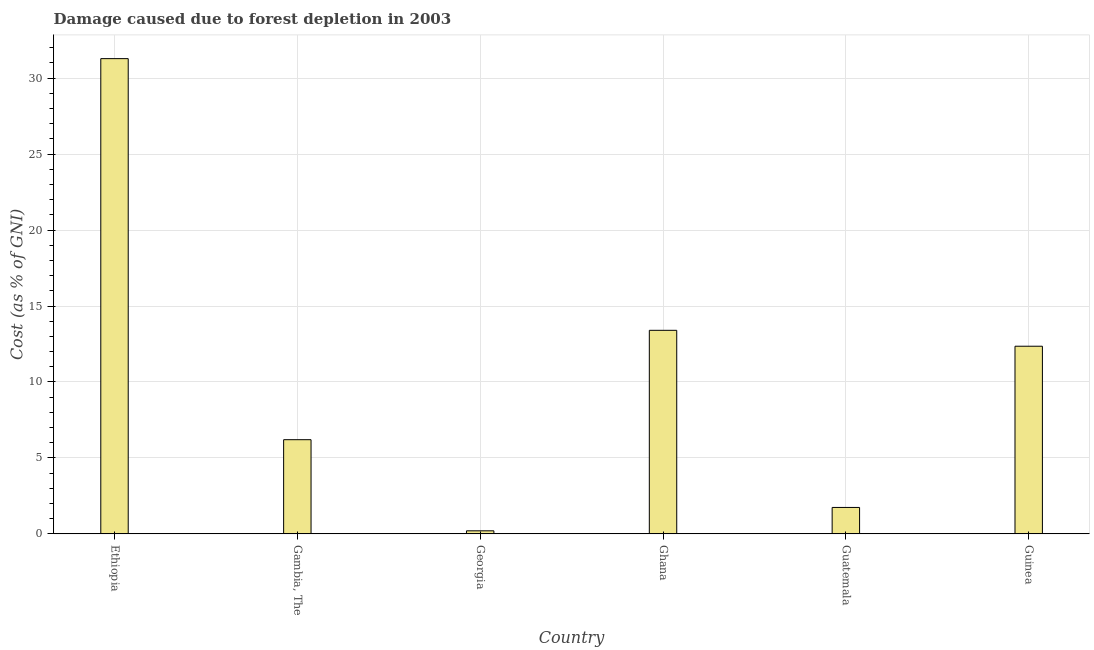Does the graph contain grids?
Your response must be concise. Yes. What is the title of the graph?
Your answer should be very brief. Damage caused due to forest depletion in 2003. What is the label or title of the Y-axis?
Offer a very short reply. Cost (as % of GNI). What is the damage caused due to forest depletion in Guatemala?
Provide a succinct answer. 1.74. Across all countries, what is the maximum damage caused due to forest depletion?
Your answer should be very brief. 31.29. Across all countries, what is the minimum damage caused due to forest depletion?
Your answer should be compact. 0.2. In which country was the damage caused due to forest depletion maximum?
Your answer should be very brief. Ethiopia. In which country was the damage caused due to forest depletion minimum?
Provide a short and direct response. Georgia. What is the sum of the damage caused due to forest depletion?
Offer a terse response. 65.18. What is the difference between the damage caused due to forest depletion in Ethiopia and Guinea?
Offer a terse response. 18.93. What is the average damage caused due to forest depletion per country?
Provide a short and direct response. 10.86. What is the median damage caused due to forest depletion?
Offer a very short reply. 9.28. What is the ratio of the damage caused due to forest depletion in Ethiopia to that in Guinea?
Provide a succinct answer. 2.53. Is the difference between the damage caused due to forest depletion in Georgia and Ghana greater than the difference between any two countries?
Offer a very short reply. No. What is the difference between the highest and the second highest damage caused due to forest depletion?
Your answer should be very brief. 17.89. Is the sum of the damage caused due to forest depletion in Gambia, The and Guatemala greater than the maximum damage caused due to forest depletion across all countries?
Your answer should be very brief. No. What is the difference between the highest and the lowest damage caused due to forest depletion?
Provide a short and direct response. 31.09. In how many countries, is the damage caused due to forest depletion greater than the average damage caused due to forest depletion taken over all countries?
Provide a short and direct response. 3. What is the difference between two consecutive major ticks on the Y-axis?
Your response must be concise. 5. What is the Cost (as % of GNI) of Ethiopia?
Keep it short and to the point. 31.29. What is the Cost (as % of GNI) in Gambia, The?
Offer a very short reply. 6.2. What is the Cost (as % of GNI) in Georgia?
Make the answer very short. 0.2. What is the Cost (as % of GNI) in Ghana?
Offer a very short reply. 13.4. What is the Cost (as % of GNI) of Guatemala?
Make the answer very short. 1.74. What is the Cost (as % of GNI) of Guinea?
Keep it short and to the point. 12.35. What is the difference between the Cost (as % of GNI) in Ethiopia and Gambia, The?
Give a very brief answer. 25.09. What is the difference between the Cost (as % of GNI) in Ethiopia and Georgia?
Make the answer very short. 31.09. What is the difference between the Cost (as % of GNI) in Ethiopia and Ghana?
Your response must be concise. 17.89. What is the difference between the Cost (as % of GNI) in Ethiopia and Guatemala?
Provide a succinct answer. 29.55. What is the difference between the Cost (as % of GNI) in Ethiopia and Guinea?
Your answer should be very brief. 18.93. What is the difference between the Cost (as % of GNI) in Gambia, The and Georgia?
Ensure brevity in your answer.  6. What is the difference between the Cost (as % of GNI) in Gambia, The and Ghana?
Provide a short and direct response. -7.2. What is the difference between the Cost (as % of GNI) in Gambia, The and Guatemala?
Make the answer very short. 4.46. What is the difference between the Cost (as % of GNI) in Gambia, The and Guinea?
Make the answer very short. -6.15. What is the difference between the Cost (as % of GNI) in Georgia and Ghana?
Your response must be concise. -13.2. What is the difference between the Cost (as % of GNI) in Georgia and Guatemala?
Offer a terse response. -1.54. What is the difference between the Cost (as % of GNI) in Georgia and Guinea?
Provide a short and direct response. -12.15. What is the difference between the Cost (as % of GNI) in Ghana and Guatemala?
Give a very brief answer. 11.66. What is the difference between the Cost (as % of GNI) in Ghana and Guinea?
Offer a terse response. 1.05. What is the difference between the Cost (as % of GNI) in Guatemala and Guinea?
Make the answer very short. -10.61. What is the ratio of the Cost (as % of GNI) in Ethiopia to that in Gambia, The?
Offer a very short reply. 5.05. What is the ratio of the Cost (as % of GNI) in Ethiopia to that in Georgia?
Your response must be concise. 155.94. What is the ratio of the Cost (as % of GNI) in Ethiopia to that in Ghana?
Keep it short and to the point. 2.33. What is the ratio of the Cost (as % of GNI) in Ethiopia to that in Guatemala?
Keep it short and to the point. 17.99. What is the ratio of the Cost (as % of GNI) in Ethiopia to that in Guinea?
Give a very brief answer. 2.53. What is the ratio of the Cost (as % of GNI) in Gambia, The to that in Georgia?
Your answer should be compact. 30.9. What is the ratio of the Cost (as % of GNI) in Gambia, The to that in Ghana?
Offer a very short reply. 0.46. What is the ratio of the Cost (as % of GNI) in Gambia, The to that in Guatemala?
Offer a very short reply. 3.57. What is the ratio of the Cost (as % of GNI) in Gambia, The to that in Guinea?
Offer a very short reply. 0.5. What is the ratio of the Cost (as % of GNI) in Georgia to that in Ghana?
Keep it short and to the point. 0.01. What is the ratio of the Cost (as % of GNI) in Georgia to that in Guatemala?
Provide a short and direct response. 0.12. What is the ratio of the Cost (as % of GNI) in Georgia to that in Guinea?
Give a very brief answer. 0.02. What is the ratio of the Cost (as % of GNI) in Ghana to that in Guatemala?
Your answer should be compact. 7.71. What is the ratio of the Cost (as % of GNI) in Ghana to that in Guinea?
Make the answer very short. 1.08. What is the ratio of the Cost (as % of GNI) in Guatemala to that in Guinea?
Provide a succinct answer. 0.14. 